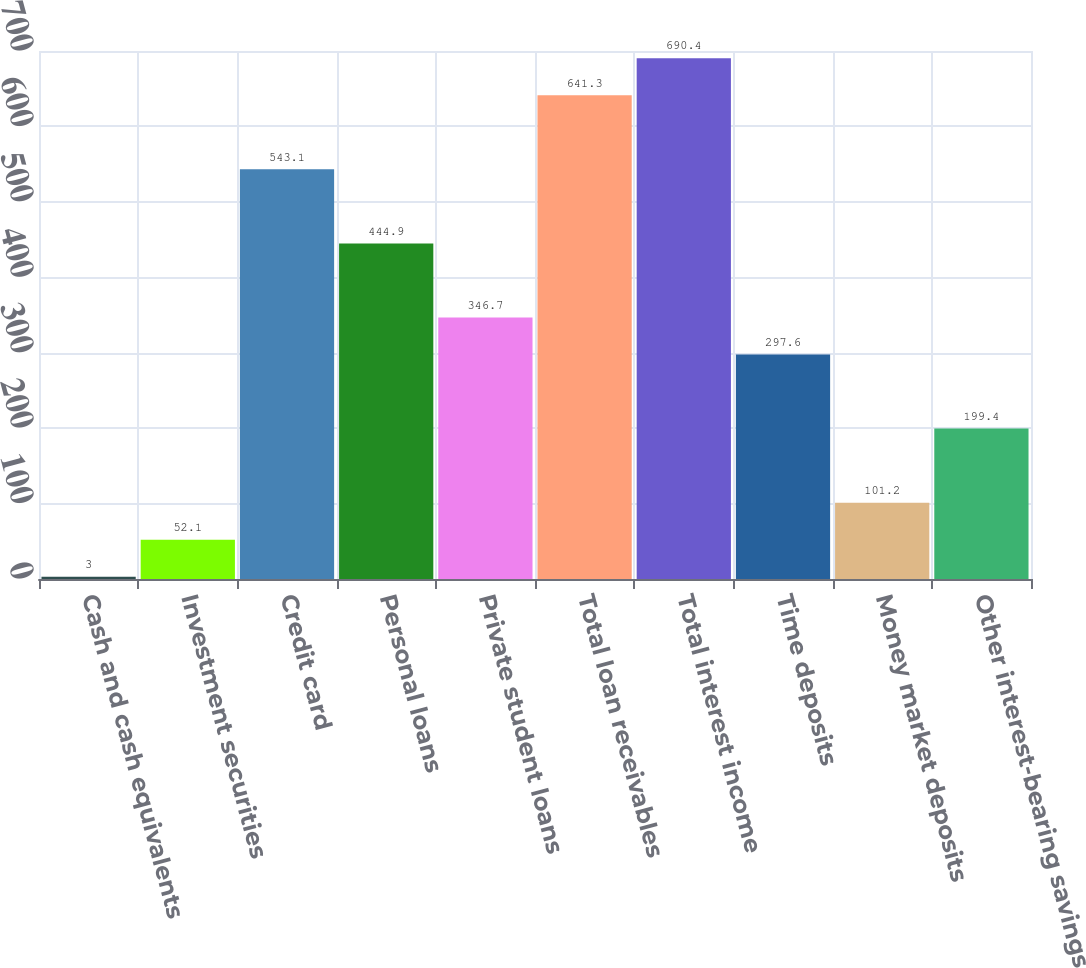Convert chart. <chart><loc_0><loc_0><loc_500><loc_500><bar_chart><fcel>Cash and cash equivalents<fcel>Investment securities<fcel>Credit card<fcel>Personal loans<fcel>Private student loans<fcel>Total loan receivables<fcel>Total interest income<fcel>Time deposits<fcel>Money market deposits<fcel>Other interest-bearing savings<nl><fcel>3<fcel>52.1<fcel>543.1<fcel>444.9<fcel>346.7<fcel>641.3<fcel>690.4<fcel>297.6<fcel>101.2<fcel>199.4<nl></chart> 